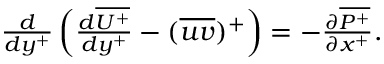<formula> <loc_0><loc_0><loc_500><loc_500>\begin{array} { r } { \frac { d } { d y ^ { + } } \left ( \frac { d \overline { { U ^ { + } } } } { d y ^ { + } } - ( \overline { u v } ) ^ { + } \right ) = - \frac { \partial \overline { { P ^ { + } } } } { \partial x ^ { + } } . } \end{array}</formula> 